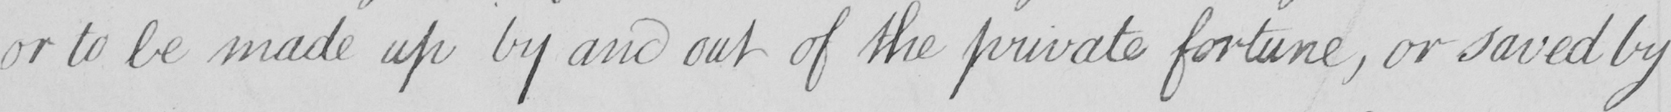Transcribe the text shown in this historical manuscript line. or to be made up by and out of the private fortune , or save by 